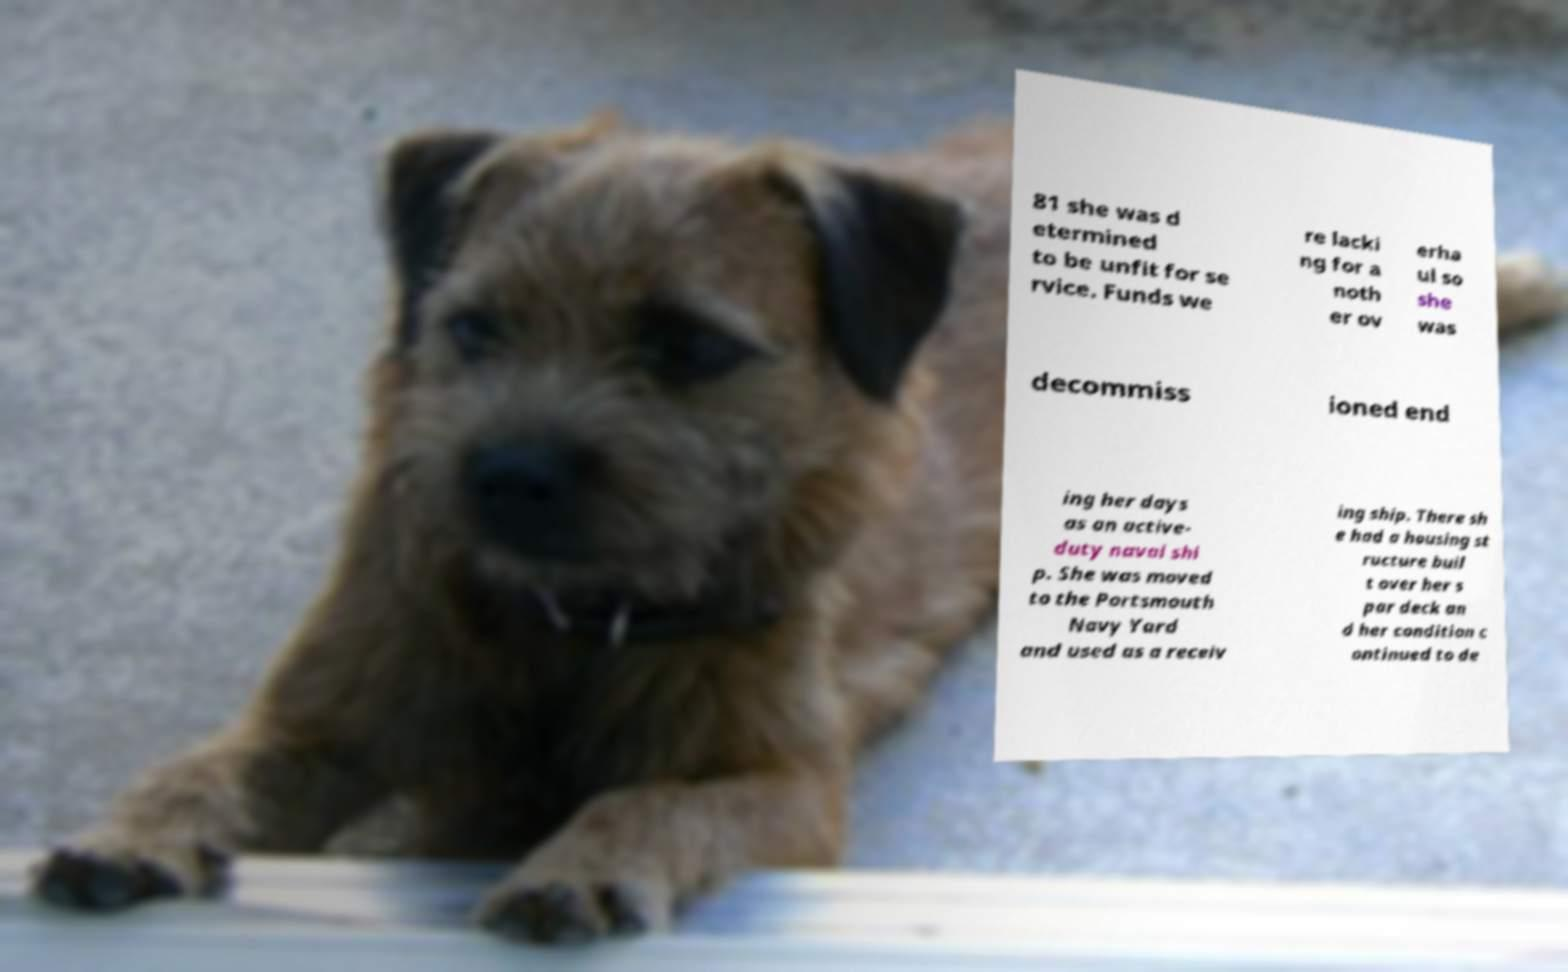Please identify and transcribe the text found in this image. 81 she was d etermined to be unfit for se rvice. Funds we re lacki ng for a noth er ov erha ul so she was decommiss ioned end ing her days as an active- duty naval shi p. She was moved to the Portsmouth Navy Yard and used as a receiv ing ship. There sh e had a housing st ructure buil t over her s par deck an d her condition c ontinued to de 